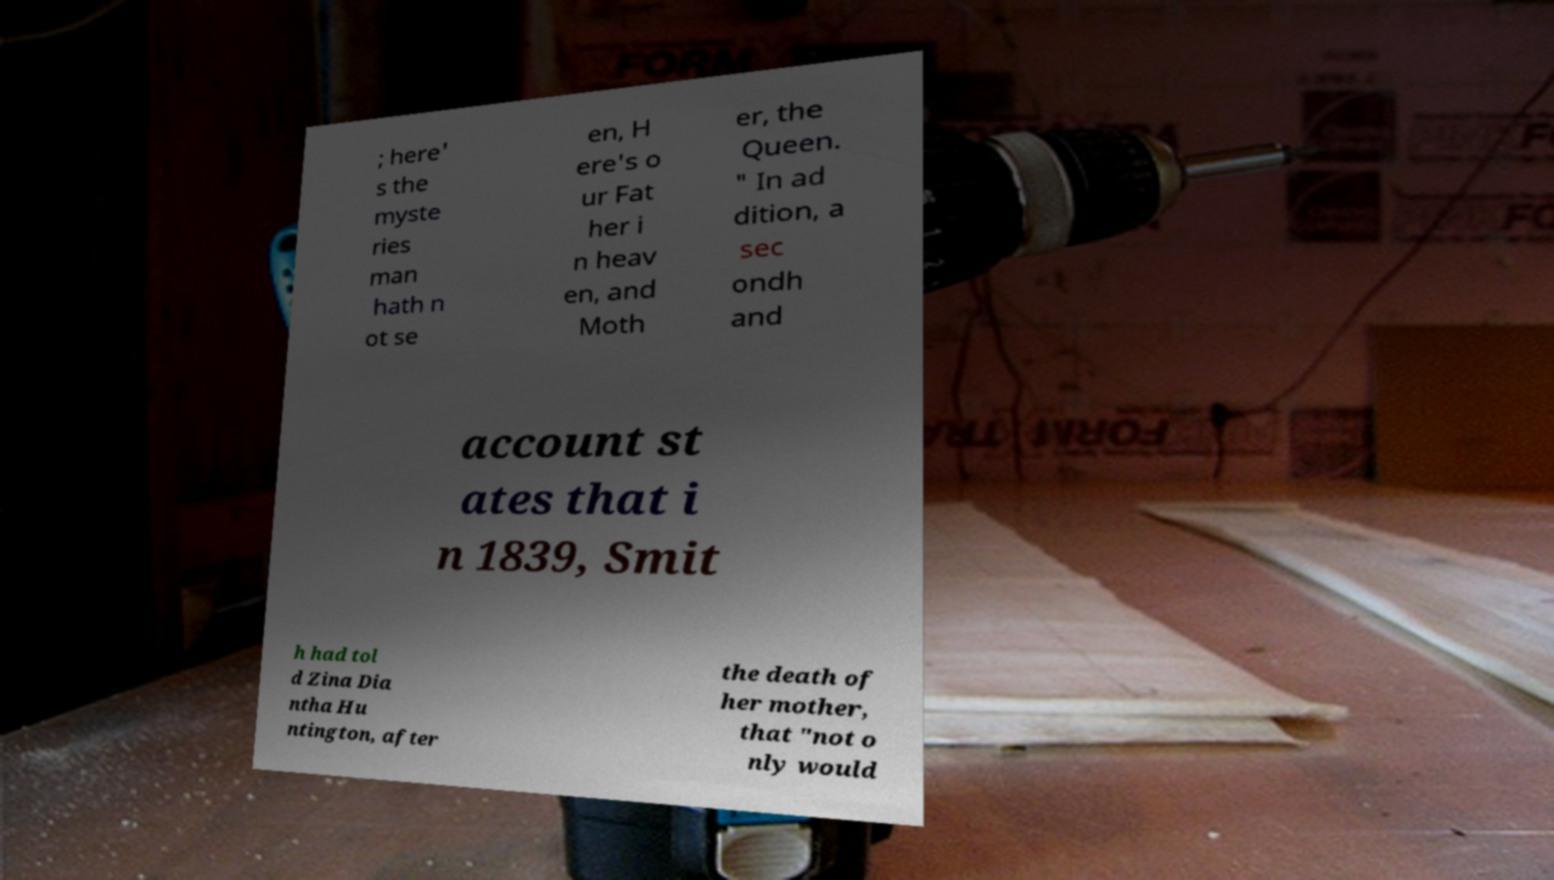Please identify and transcribe the text found in this image. ; here' s the myste ries man hath n ot se en, H ere's o ur Fat her i n heav en, and Moth er, the Queen. " In ad dition, a sec ondh and account st ates that i n 1839, Smit h had tol d Zina Dia ntha Hu ntington, after the death of her mother, that "not o nly would 